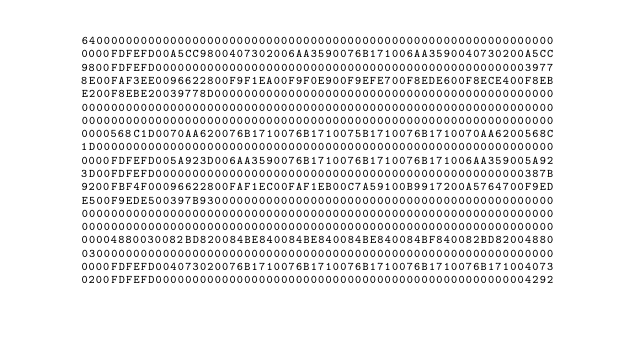<code> <loc_0><loc_0><loc_500><loc_500><_Pascal_>      6400000000000000000000000000000000000000000000000000000000000000
      0000FDFEFD00A5CC9800407302006AA3590076B171006AA3590040730200A5CC
      9800FDFEFD000000000000000000000000000000000000000000000000003977
      8E00FAF3EE0096622800F9F1EA00F9F0E900F9EFE700F8EDE600F8ECE400F8EB
      E200F8EBE20039778D0000000000000000000000000000000000000000000000
      0000000000000000000000000000000000000000000000000000000000000000
      0000000000000000000000000000000000000000000000000000000000000000
      0000568C1D0070AA620076B1710076B1710075B1710076B1710070AA6200568C
      1D00000000000000000000000000000000000000000000000000000000000000
      0000FDFEFD005A923D006AA3590076B1710076B1710076B171006AA359005A92
      3D00FDFEFD00000000000000000000000000000000000000000000000000387B
      9200FBF4F00096622800FAF1EC00FAF1EB00C7A59100B9917200A5764700F9ED
      E500F9EDE500397B930000000000000000000000000000000000000000000000
      0000000000000000000000000000000000000000000000000000000000000000
      0000000000000000000000000000000000000000000000000000000000000000
      00004880030082BD820084BE840084BE840084BE840084BF840082BD82004880
      0300000000000000000000000000000000000000000000000000000000000000
      0000FDFEFD004073020076B1710076B1710076B1710076B1710076B171004073
      0200FDFEFD000000000000000000000000000000000000000000000000004292</code> 